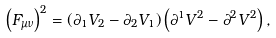Convert formula to latex. <formula><loc_0><loc_0><loc_500><loc_500>\left ( { F _ { \mu \nu } } \right ) ^ { 2 } = \left ( { \partial _ { 1 } V _ { 2 } - \partial _ { 2 } V _ { 1 } } \right ) \left ( { \partial ^ { 1 } V ^ { 2 } - \partial ^ { 2 } V ^ { 2 } } \right ) ,</formula> 